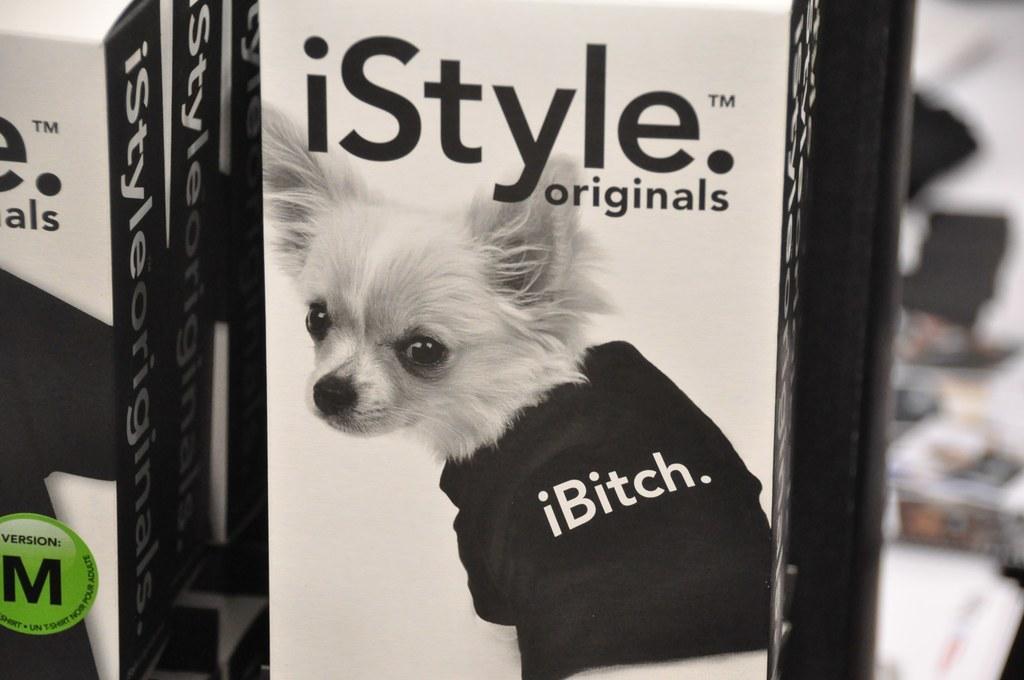Please provide a concise description of this image. In this image I can see a dog wearing black color dress. I can see a white and black color boxes and something is written on it. Background is blurred. 